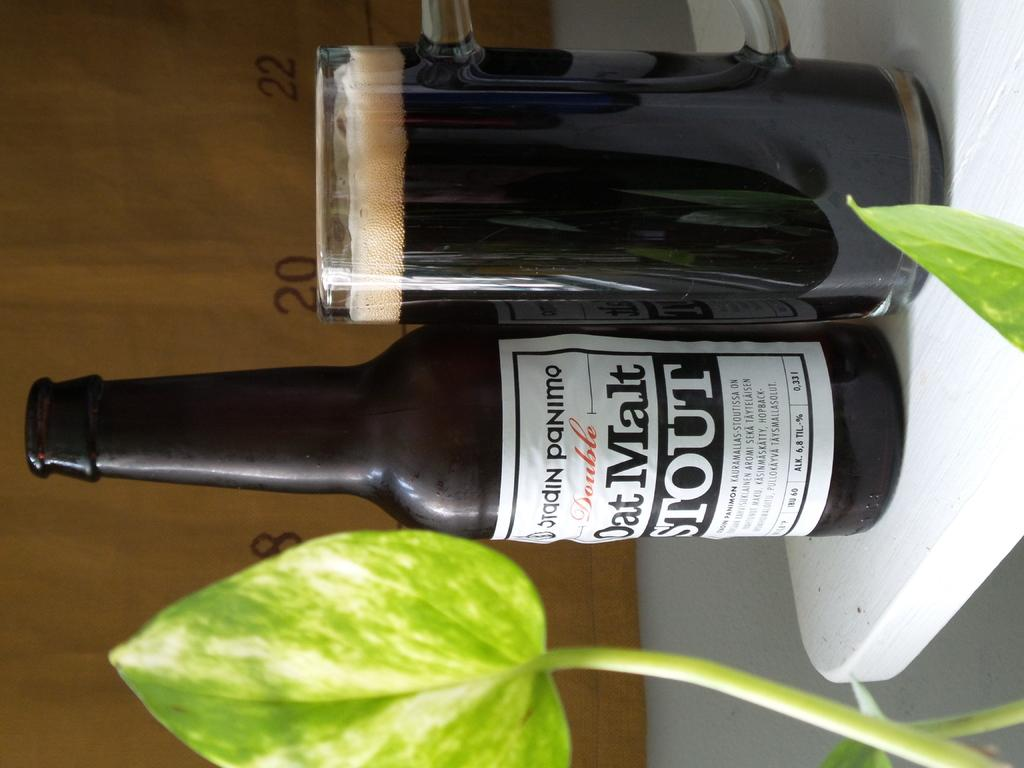Provide a one-sentence caption for the provided image. A bottle of Oat Moat stout stands on a white table next to a full glass of the same liquid. 